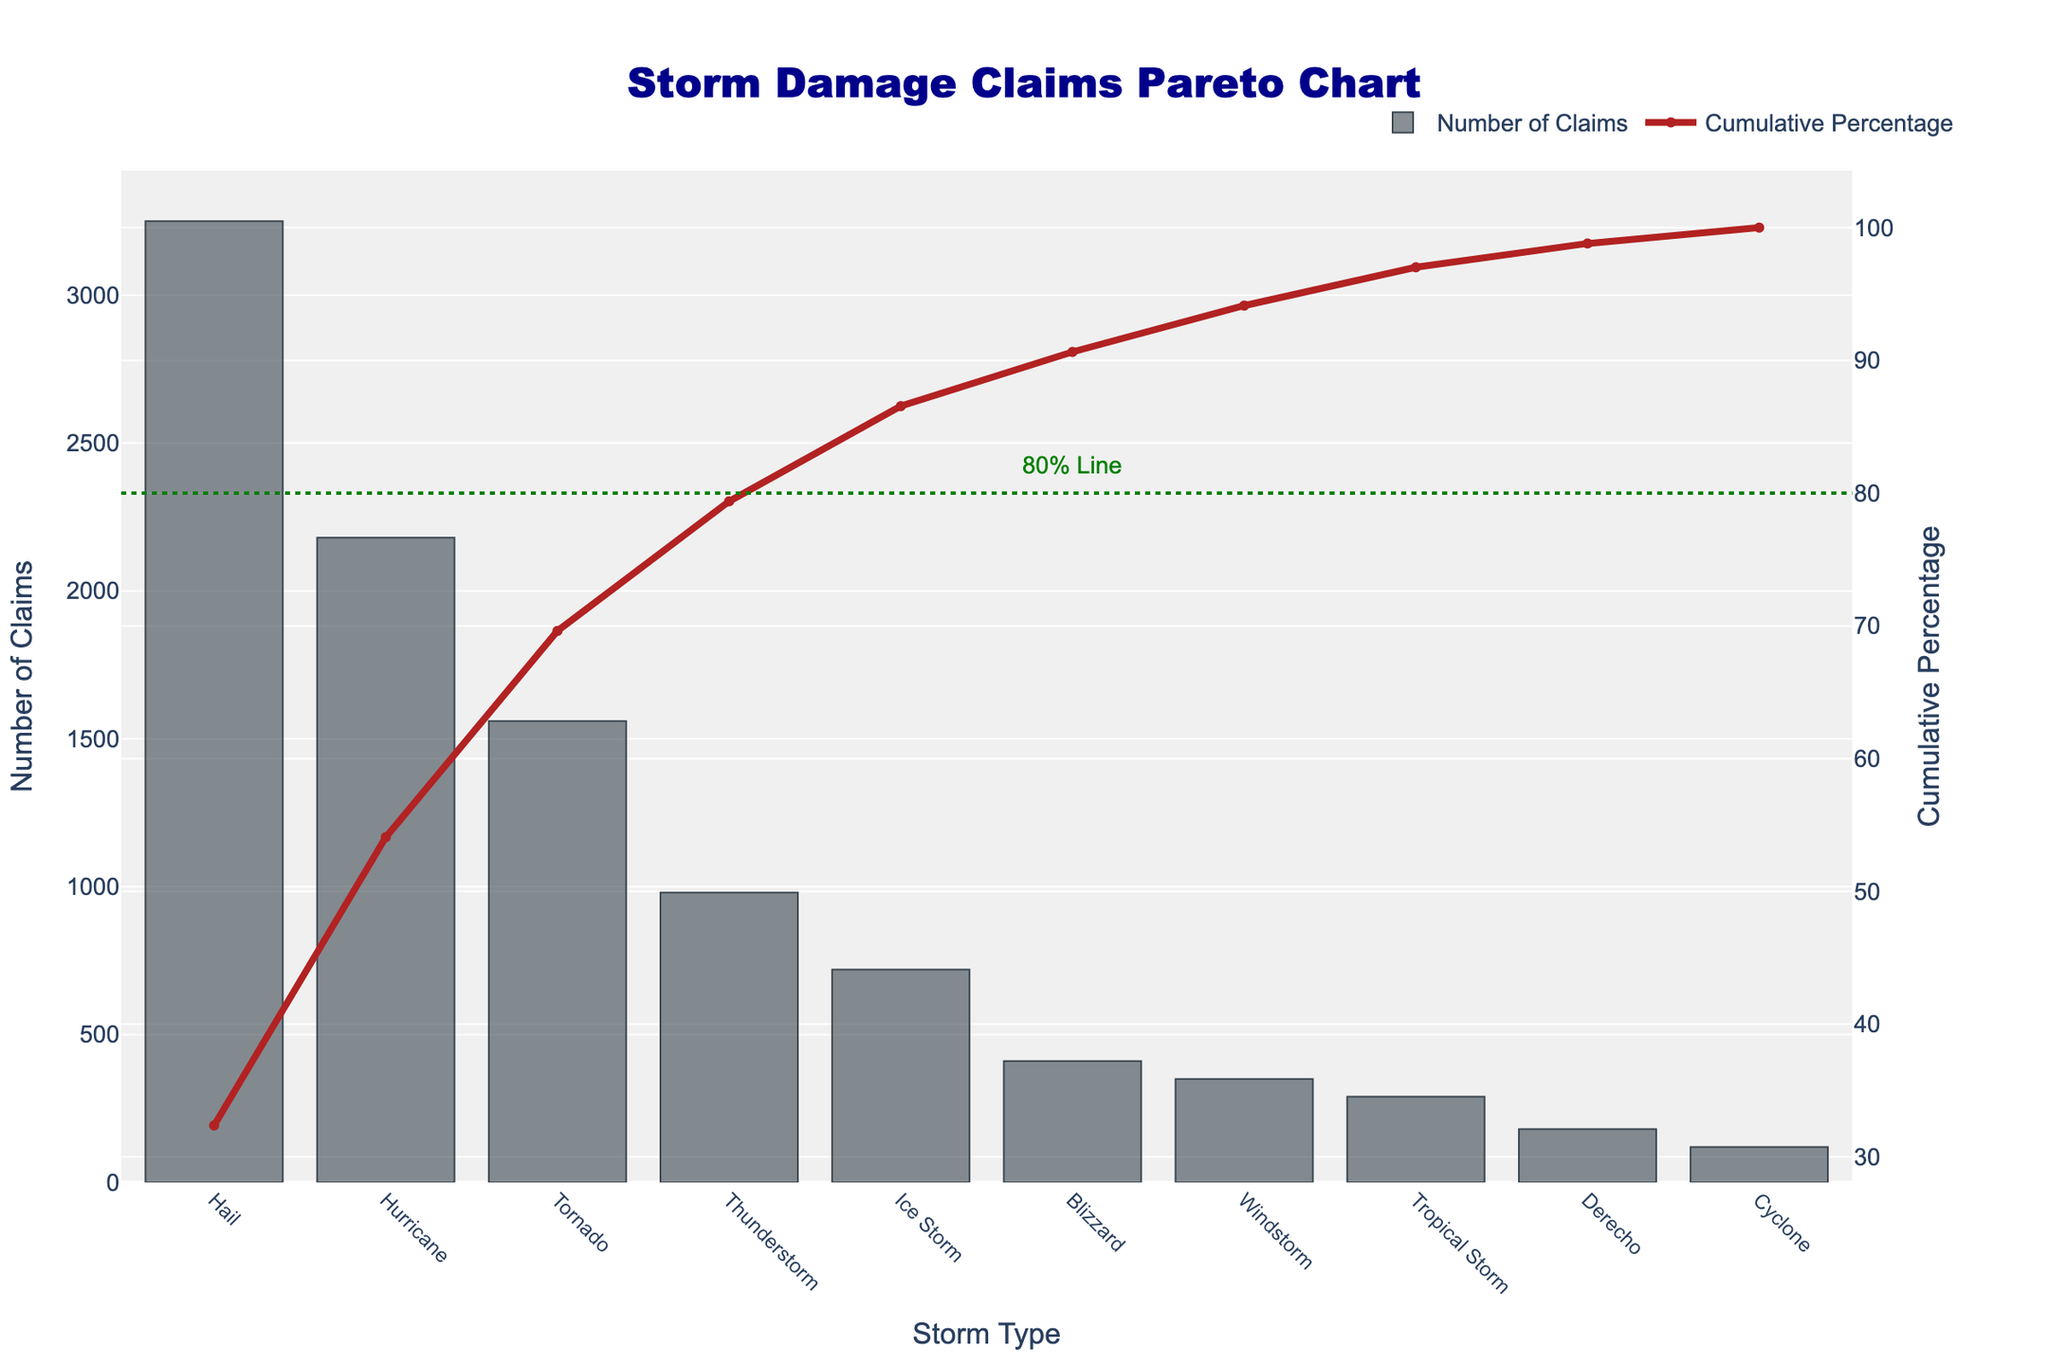What is the title of the figure? The title of the figure is prominently displayed at the top. It reads, "Storm Damage Claims Pareto Chart".
Answer: Storm Damage Claims Pareto Chart Which storm type has the highest number of claims? By examining the bar chart, the storm type with the highest bar represents the highest number of claims. The highest bar corresponds to "Hail," with 3,250 claims.
Answer: Hail What percentage of claims are cumulatively accounted for by the top three storm types? Referring to the cumulative percentage line, sum the percentages for "Hail," "Hurricane," and "Tornado." "Hail" is at 37.15%, "Hurricane" at 62.84%, and "Tornado" at 80.67%. Adding these gives 80.67%.
Answer: 80.67% How many storm types cumulatively account for more than 80% of the claims? Observe the cumulative percentage line and the 80% reference line. The line crosses the 80% mark after three storm types: "Hail," "Hurricane," and "Tornado."
Answer: 3 Which storm type has the lowest number of claims? By examining the bar chart, the storm type with the lowest bar represents the lowest number of claims. The lowest bar corresponds to "Cyclone," with 120 claims.
Answer: Cyclone What are the two storm types with the smallest number of claims combined? By identifying the two smallest bars, we find "Cyclone" (120 claims) and "Derecho" (180 claims). Their combined number is 120 + 180 = 300 claims.
Answer: 300 What is the difference in the number of claims between Hurricane and Tornado? From the bar chart, Hurricane has 2,180 claims and Tornado has 1,560 claims. The difference is 2,180 - 1,560 = 620 claims.
Answer: 620 What is the cumulative percentage for Thunderstorm? By checking the data points corresponding to "Thunderstorm," the cumulative percentage line meets at approximately 91%.
Answer: 91% Which storm types fall below the 80% cumulative line? Identify the storm types before reaching the 80% cumulative line. These are "Hail," "Hurricane," and "Tornado."
Answer: Hail, Hurricane, Tornado How many storm types have more than 1,000 claims? By observing the bar chart, count the storm types with bars extending beyond the 1,000 claims mark. These are "Hail" (3,250), "Hurricane" (2,180), and "Tornado" (1,560). Thus, 3 storm types qualify.
Answer: 3 